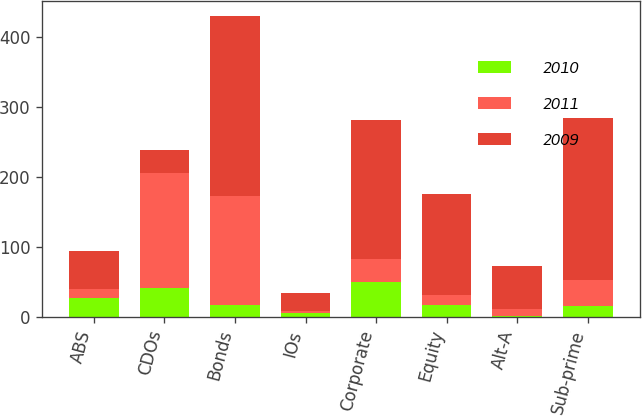Convert chart to OTSL. <chart><loc_0><loc_0><loc_500><loc_500><stacked_bar_chart><ecel><fcel>ABS<fcel>CDOs<fcel>Bonds<fcel>IOs<fcel>Corporate<fcel>Equity<fcel>Alt-A<fcel>Sub-prime<nl><fcel>2010<fcel>27<fcel>41<fcel>16<fcel>5<fcel>50<fcel>17<fcel>1<fcel>15<nl><fcel>2011<fcel>13<fcel>164<fcel>157<fcel>3<fcel>33<fcel>14<fcel>10<fcel>37<nl><fcel>2009<fcel>54<fcel>33<fcel>257<fcel>25<fcel>198<fcel>145<fcel>62<fcel>232<nl></chart> 